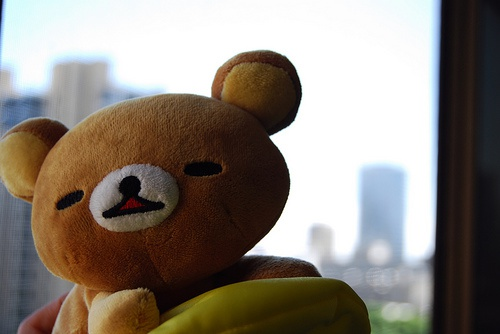Describe the objects in this image and their specific colors. I can see a teddy bear in black, maroon, and olive tones in this image. 